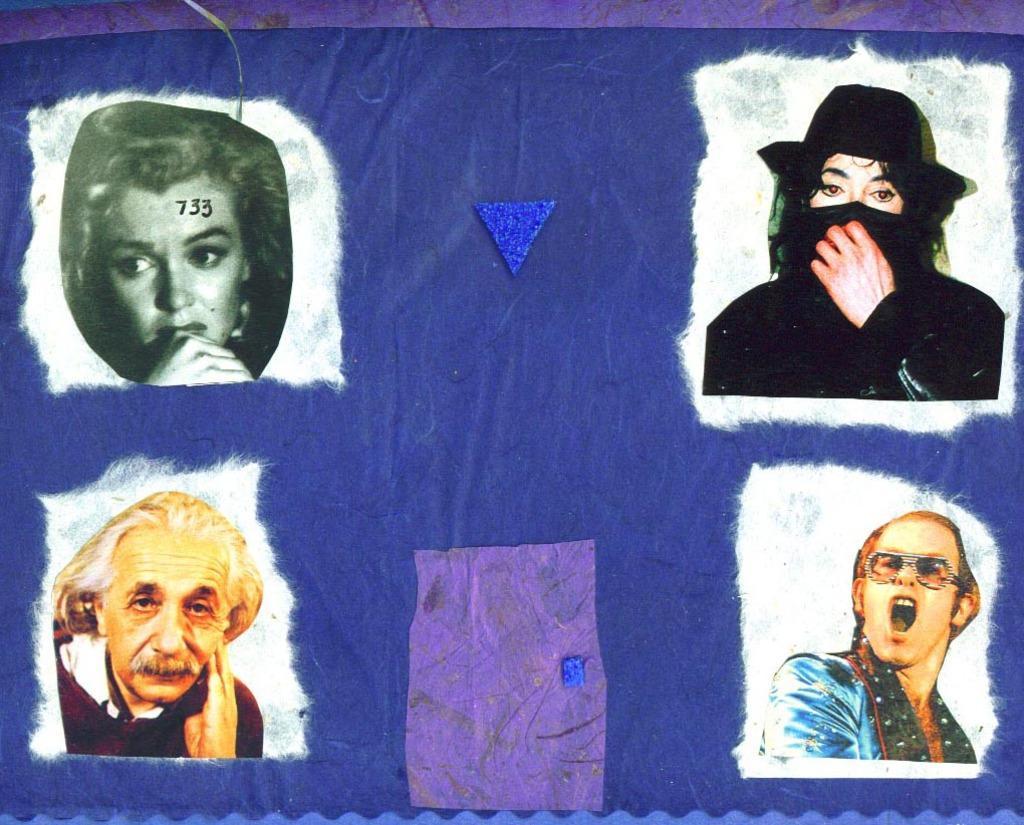Could you give a brief overview of what you see in this image? In this image we can see a banner with images, numbers and objects. 